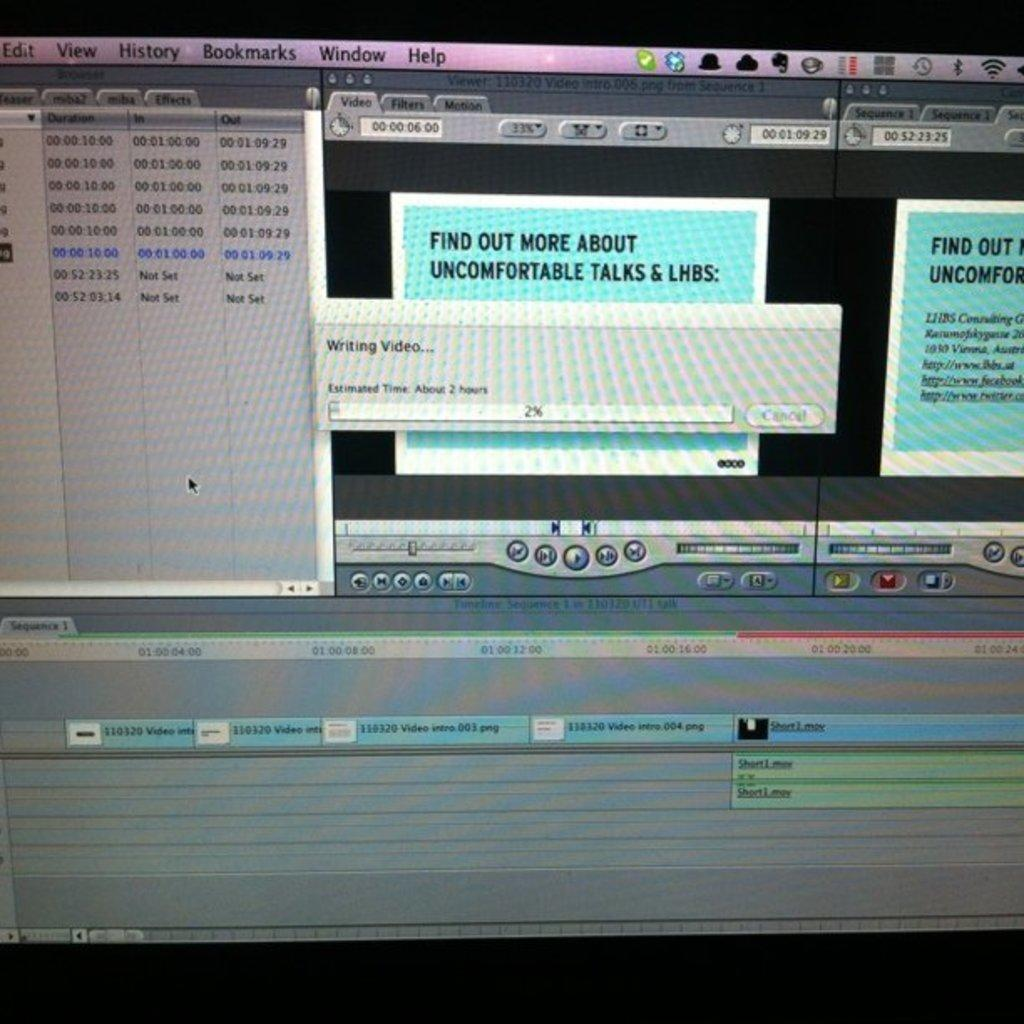<image>
Give a short and clear explanation of the subsequent image. Computer screen that tells the user to "Find out more about uncomfortable talks". 